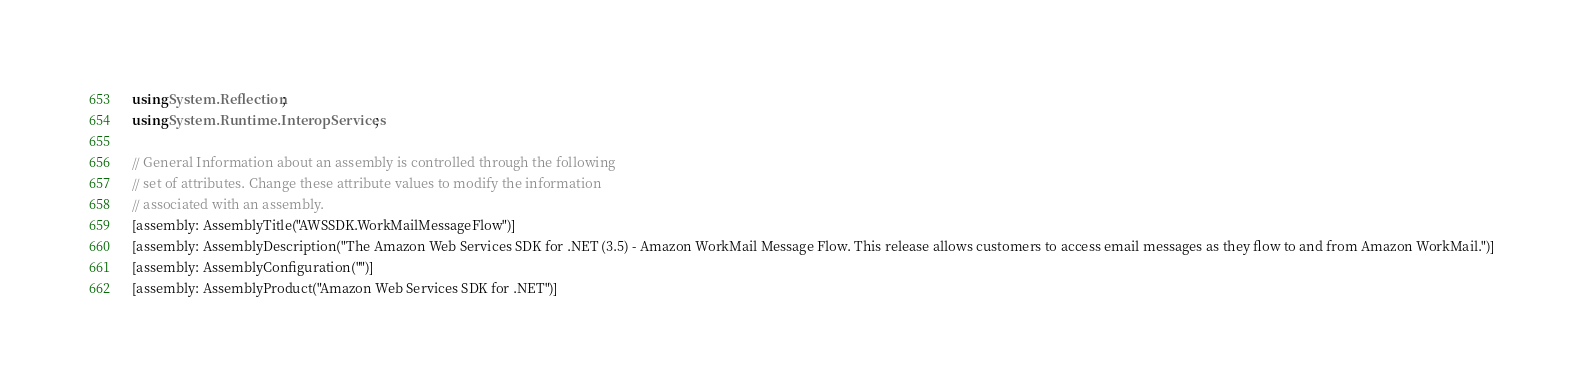<code> <loc_0><loc_0><loc_500><loc_500><_C#_>using System.Reflection;
using System.Runtime.InteropServices;

// General Information about an assembly is controlled through the following 
// set of attributes. Change these attribute values to modify the information
// associated with an assembly.
[assembly: AssemblyTitle("AWSSDK.WorkMailMessageFlow")]
[assembly: AssemblyDescription("The Amazon Web Services SDK for .NET (3.5) - Amazon WorkMail Message Flow. This release allows customers to access email messages as they flow to and from Amazon WorkMail.")]
[assembly: AssemblyConfiguration("")]
[assembly: AssemblyProduct("Amazon Web Services SDK for .NET")]</code> 